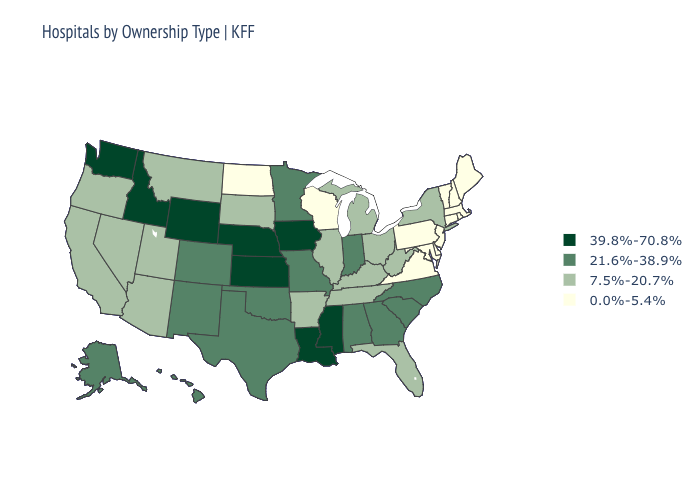What is the value of Wyoming?
Give a very brief answer. 39.8%-70.8%. Does Massachusetts have a lower value than Vermont?
Short answer required. No. Which states have the lowest value in the Northeast?
Be succinct. Connecticut, Maine, Massachusetts, New Hampshire, New Jersey, Pennsylvania, Rhode Island, Vermont. Among the states that border Kansas , does Oklahoma have the highest value?
Concise answer only. No. Does New Hampshire have the same value as Virginia?
Quick response, please. Yes. What is the lowest value in the USA?
Answer briefly. 0.0%-5.4%. Does North Carolina have the lowest value in the South?
Answer briefly. No. What is the lowest value in states that border Virginia?
Quick response, please. 0.0%-5.4%. Which states have the lowest value in the USA?
Be succinct. Connecticut, Delaware, Maine, Maryland, Massachusetts, New Hampshire, New Jersey, North Dakota, Pennsylvania, Rhode Island, Vermont, Virginia, Wisconsin. Name the states that have a value in the range 21.6%-38.9%?
Write a very short answer. Alabama, Alaska, Colorado, Georgia, Hawaii, Indiana, Minnesota, Missouri, New Mexico, North Carolina, Oklahoma, South Carolina, Texas. Name the states that have a value in the range 39.8%-70.8%?
Keep it brief. Idaho, Iowa, Kansas, Louisiana, Mississippi, Nebraska, Washington, Wyoming. What is the value of Georgia?
Short answer required. 21.6%-38.9%. Does the first symbol in the legend represent the smallest category?
Short answer required. No. Does the map have missing data?
Keep it brief. No. Does Kansas have the lowest value in the MidWest?
Write a very short answer. No. 